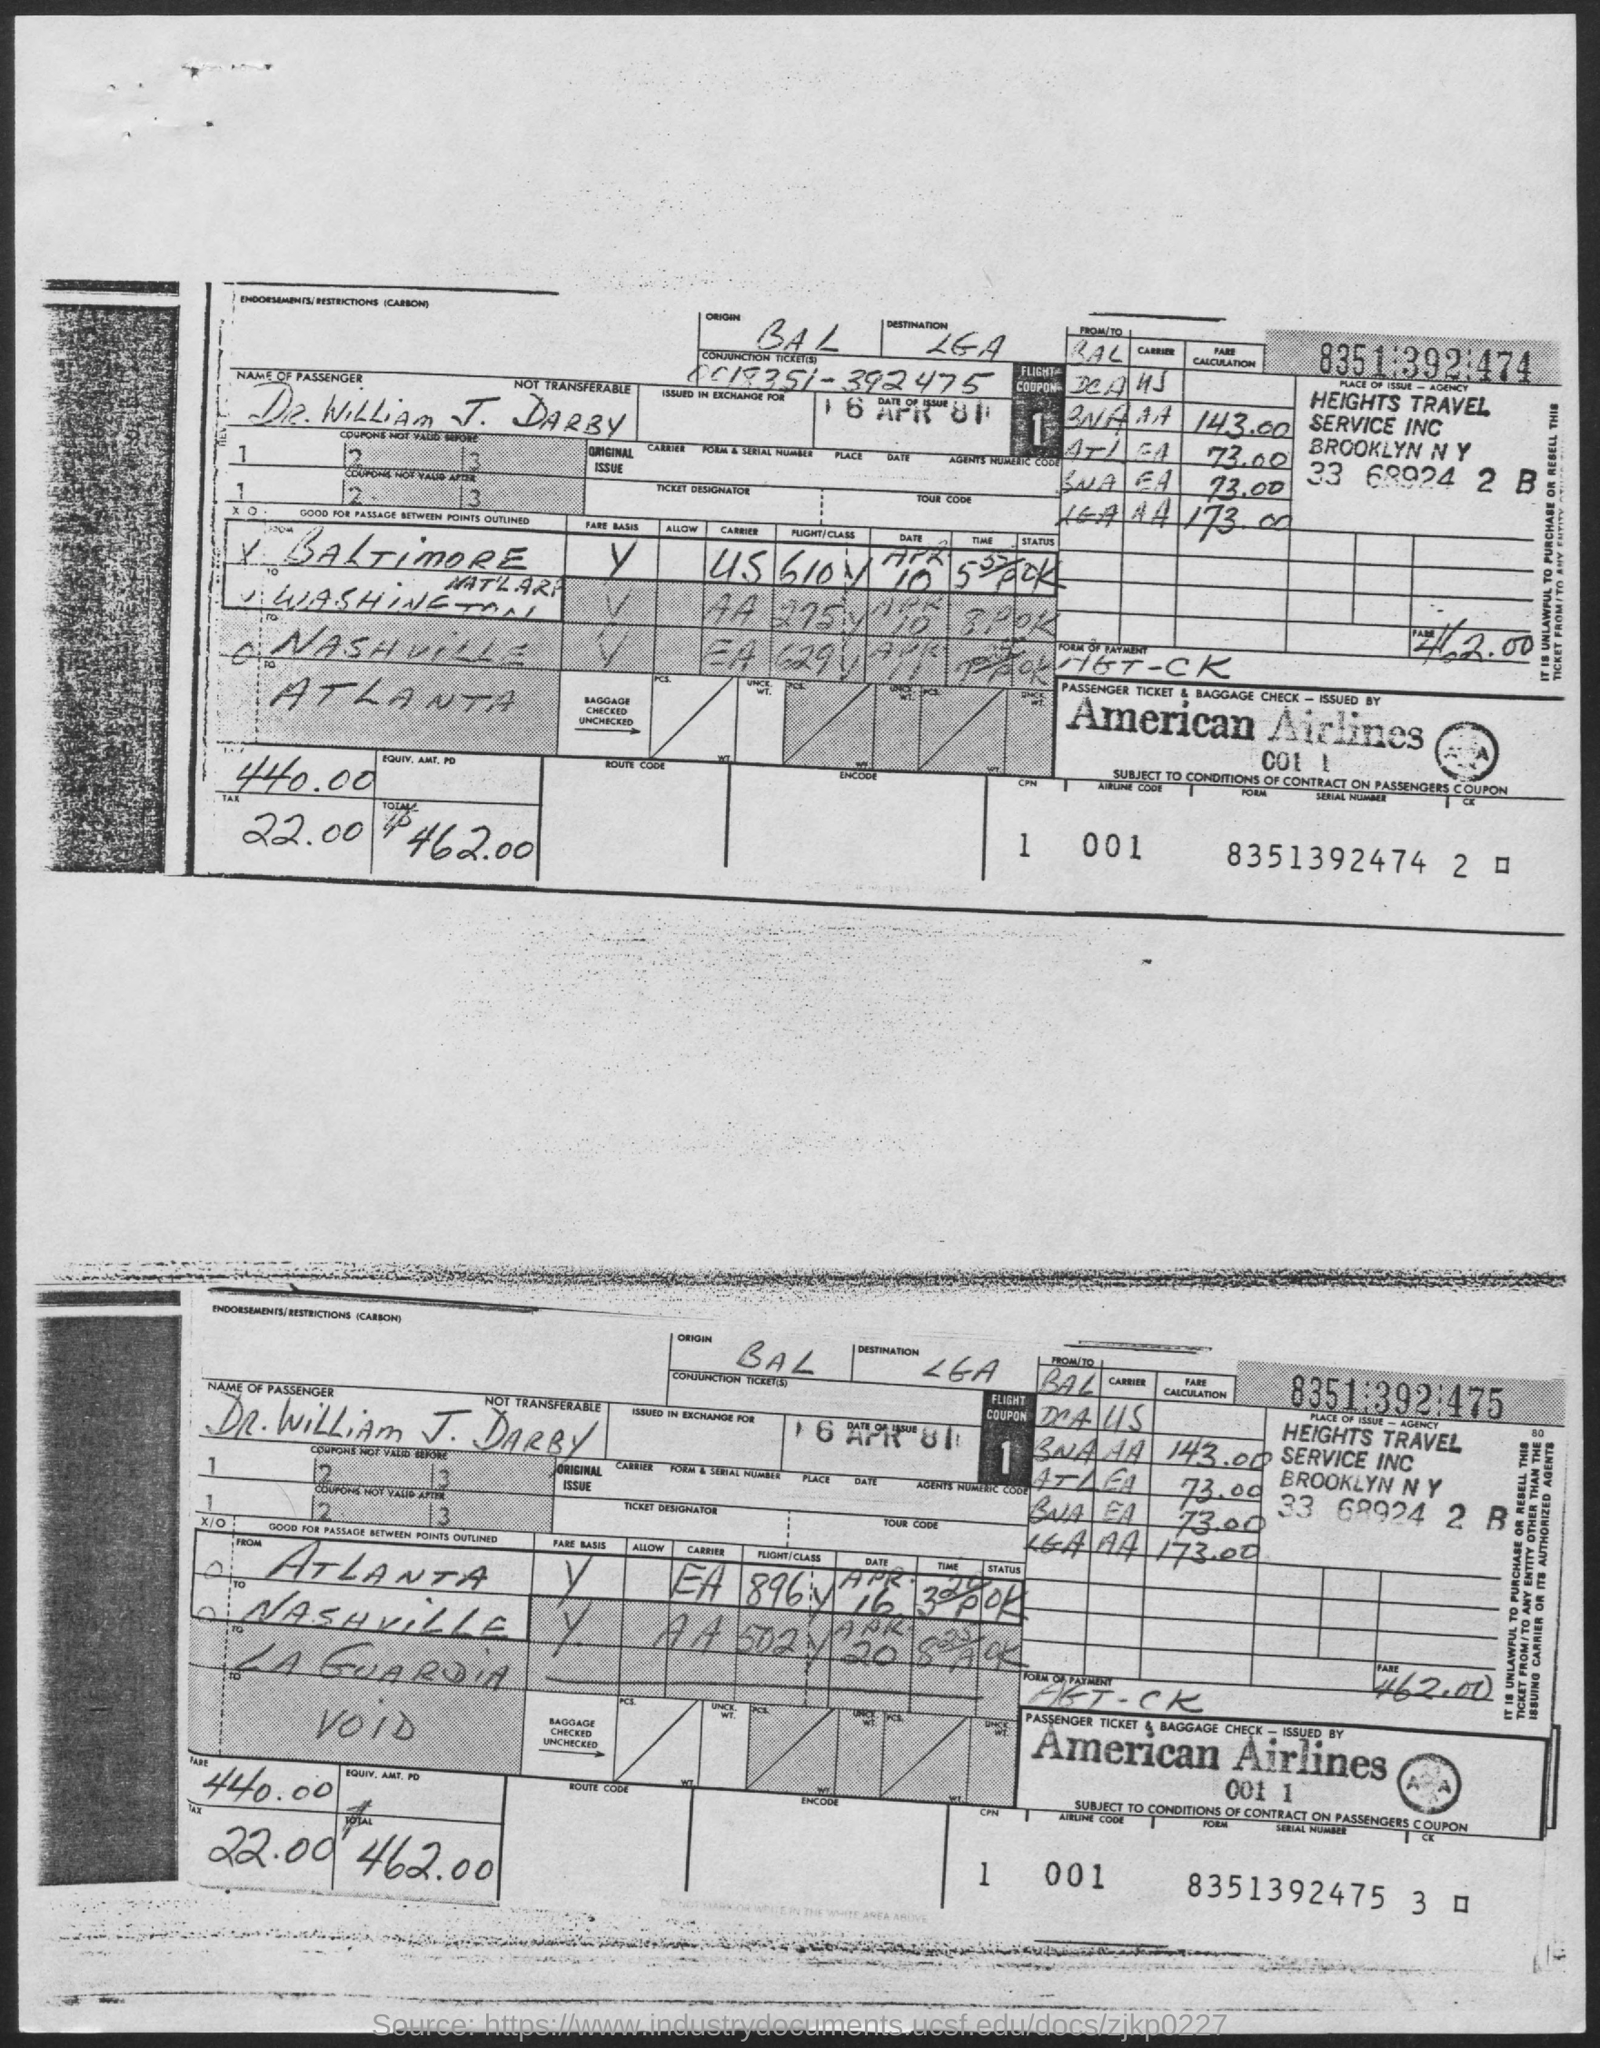What is the Name of Passenger?
Ensure brevity in your answer.  Dr. William J. Darby. What is the fare?
Give a very brief answer. 440.00. What is the Tax?
Provide a succinct answer. 22.00. What is the Total?
Keep it short and to the point. $ 462.00. What is the Destination?
Keep it short and to the point. LGA. What is the Origin?
Your answer should be very brief. BAL. 